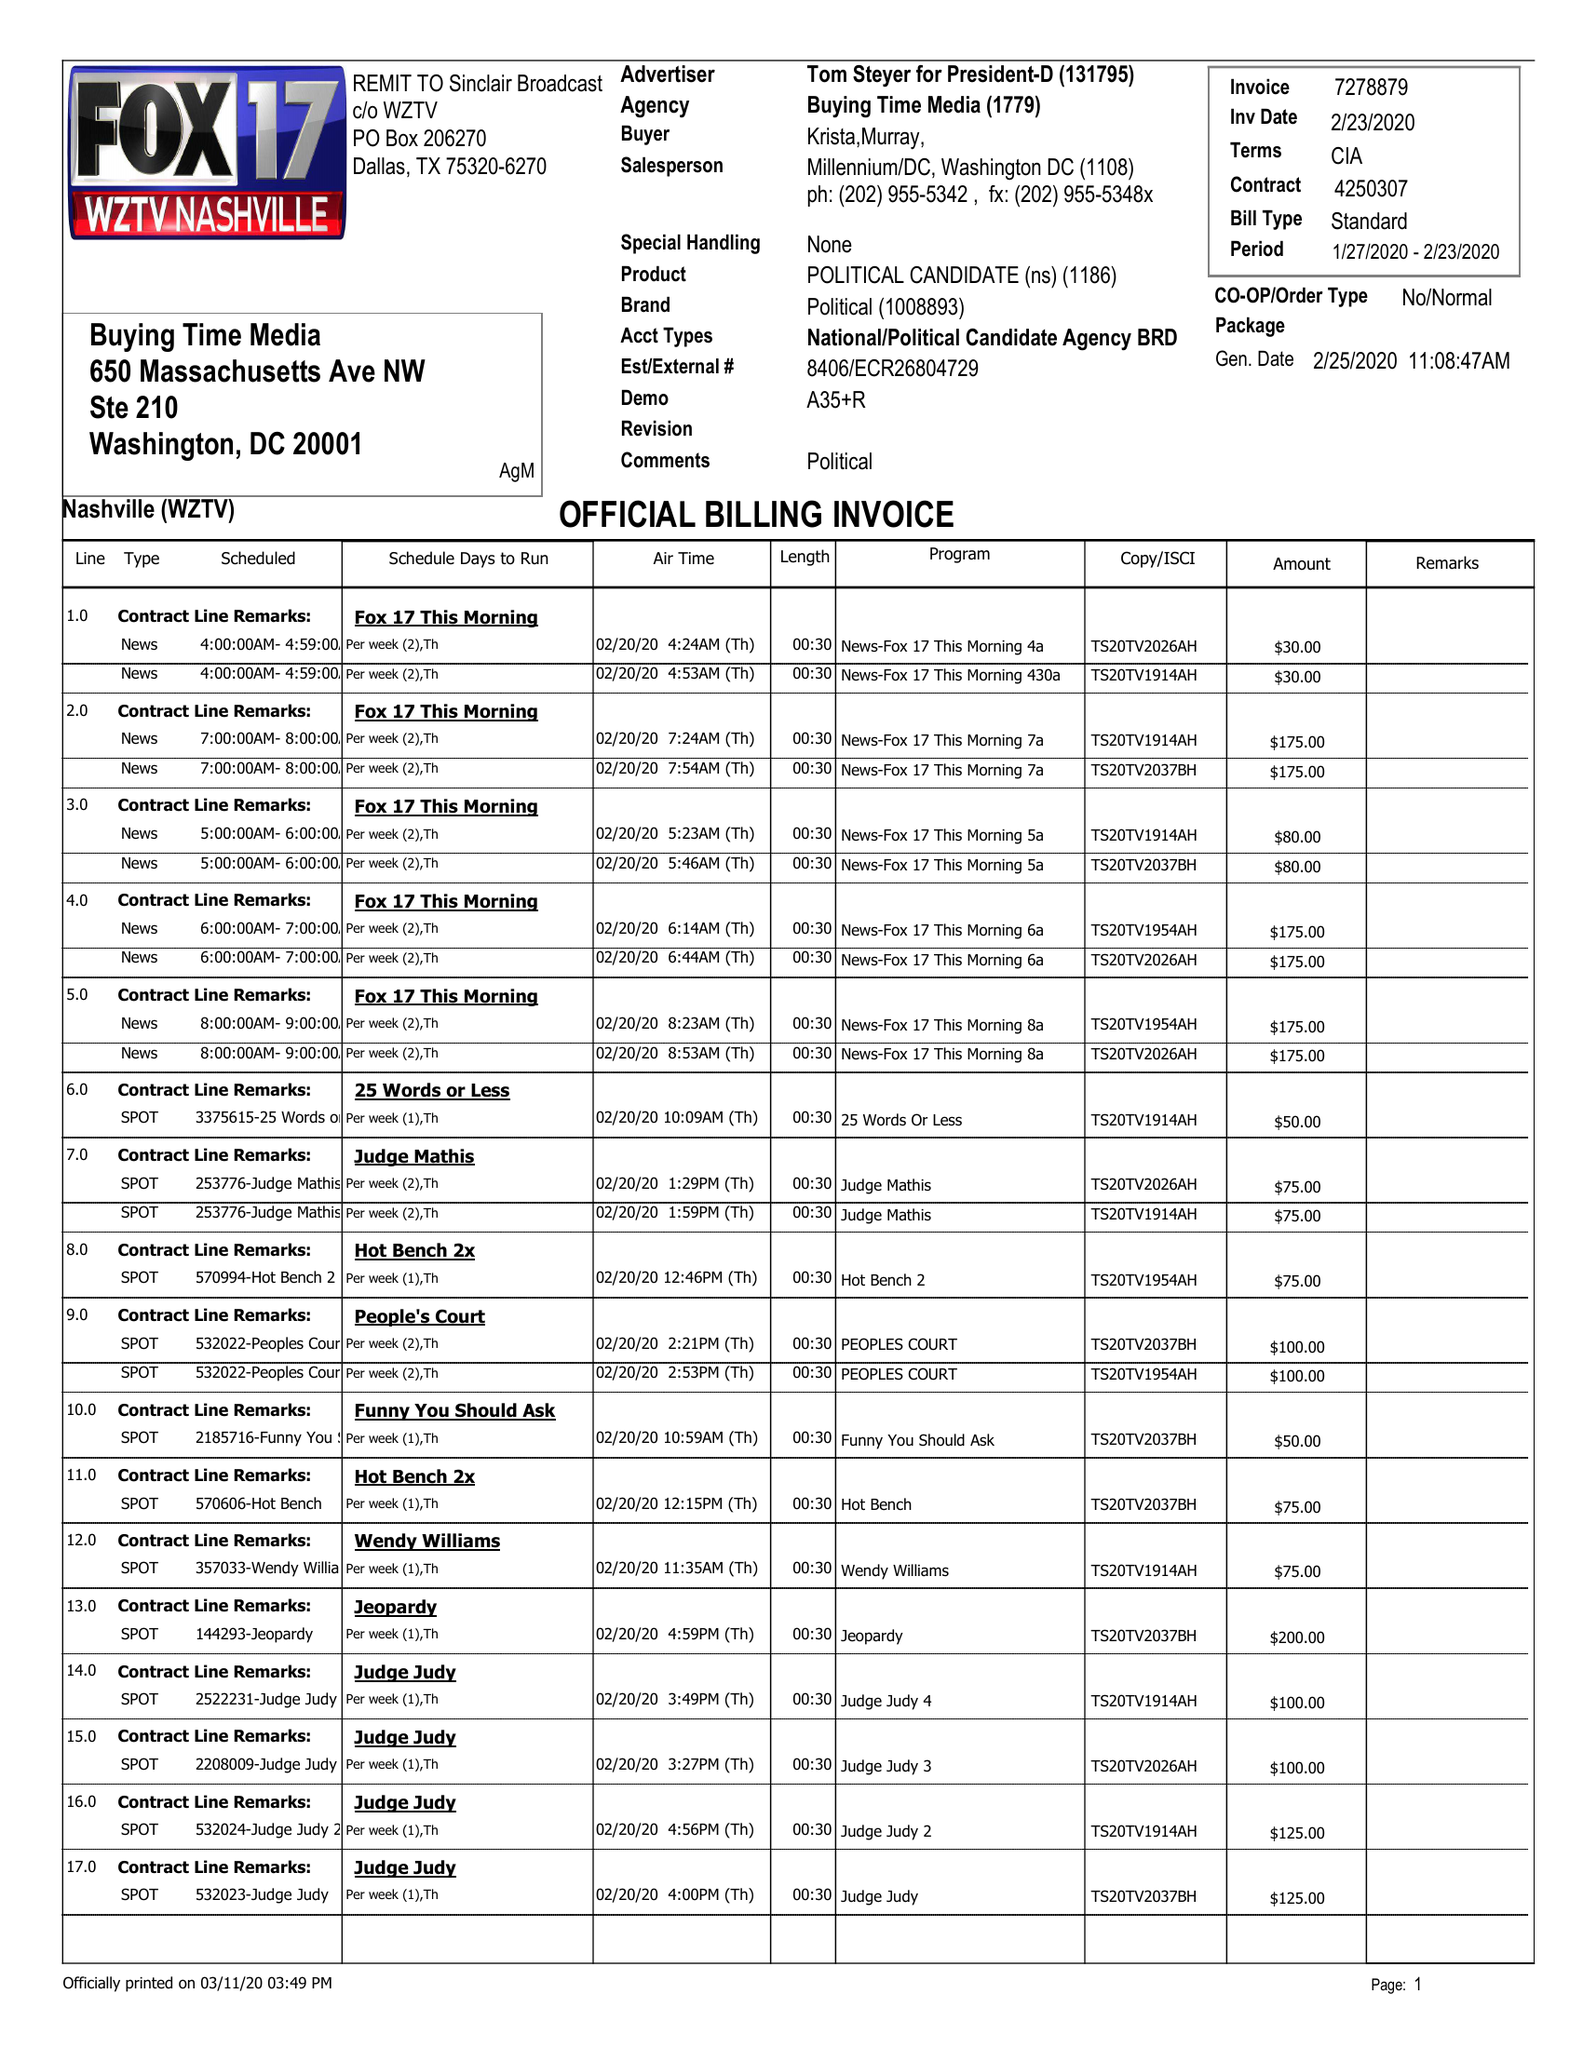What is the value for the flight_to?
Answer the question using a single word or phrase. 02/23/20 